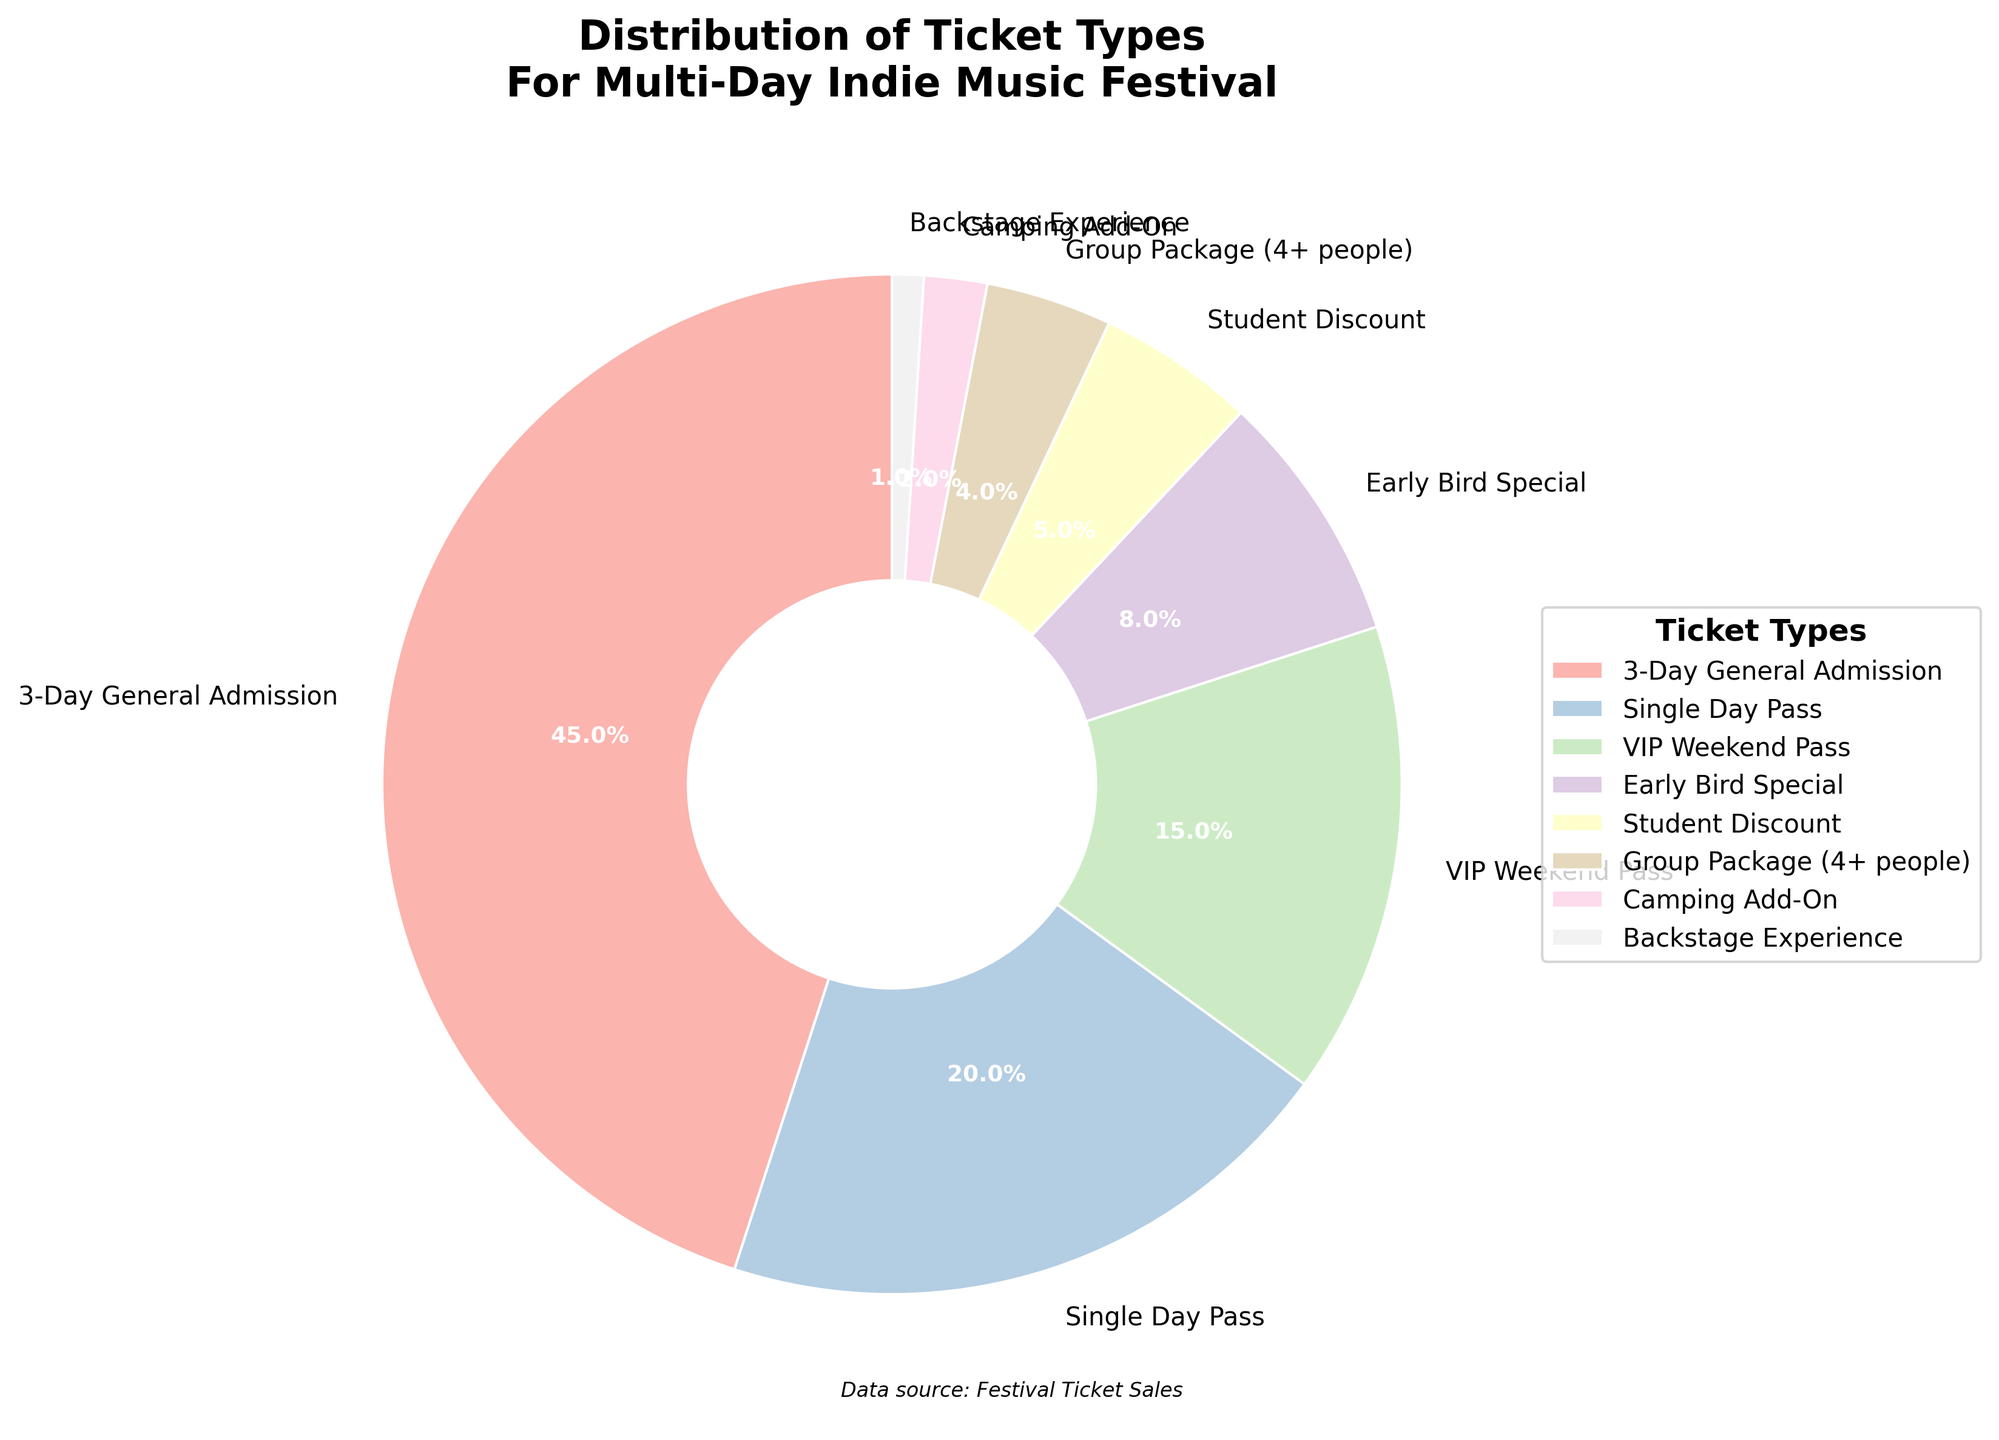What percentage of tickets sold were either VIP Weekend Pass or Student Discount? Add the percentages for VIP Weekend Pass and Student Discount: 15% + 5% = 20%
Answer: 20% Which ticket type had the lowest percentage of sales? Identify the wedge with the smallest area in the pie chart, which is labeled Backstage Experience with 1%
Answer: Backstage Experience What is the difference in percentage between Single Day Pass and Group Package (4+ people)? Subtract the percentage of Group Package (4+ people) from Single Day Pass: 20% - 4% = 16%
Answer: 16% How many ticket types sold made up more than 10% each? Identify the ticket types with percentages above 10%: 3-Day General Admission (45%) and Single Day Pass (20%), and VIP Weekend Pass (15%)
Answer: 3 How much more popular is the 3-Day General Admission compared to Early Bird Special in percentage terms? Subtract the percentage of Early Bird Special from 3-Day General Admission: 45% - 8% = 37%
Answer: 37% What tickets together account for less than 10% of total sales? Identify the ticket types with percentages below 10%: Early Bird Special (8%), Student Discount (5%), Group Package (4+ people) (4%), Camping Add-On (2%), and Backstage Experience (1%)
Answer: Early Bird Special, Student Discount, Group Package (4+ people), Camping Add-On, Backstage Experience Which two ticket types combined almost equal the percentage of Single Day Pass? Find two ticket types whose percentages sum to approximately the percentage of Single Day Pass (20%): Early Bird Special (8%) + Student Discount (5%) + Group Package (4+ people) (4%) + Camping Add-On (2%) + Backstage Experience (1%) = 20%
Answer: Early Bird Special and Student Discount, Group Package, Camping Add-On, and Backstage Experience 